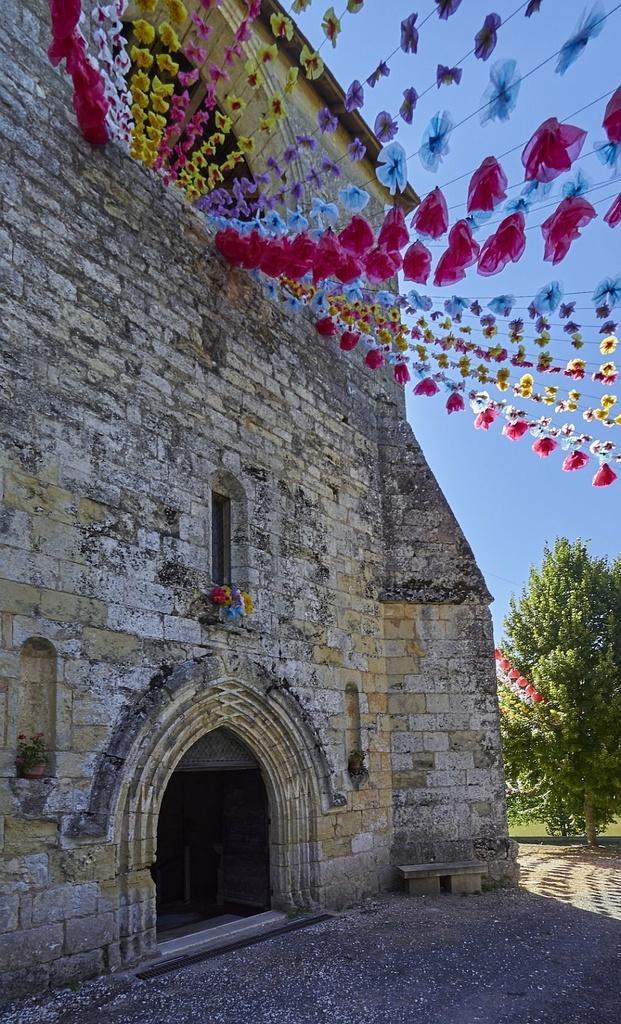In one or two sentences, can you explain what this image depicts? In this picture, we see a castle or a building which is made up of stones. We see the building is decorated with the different kinds of plastic flowers, which are in pink, blue, violet and yellow color. On the right side, we see a tree. Beside that, we see a bench. At the bottom, we see the pavement. In the background, we see the sky. 